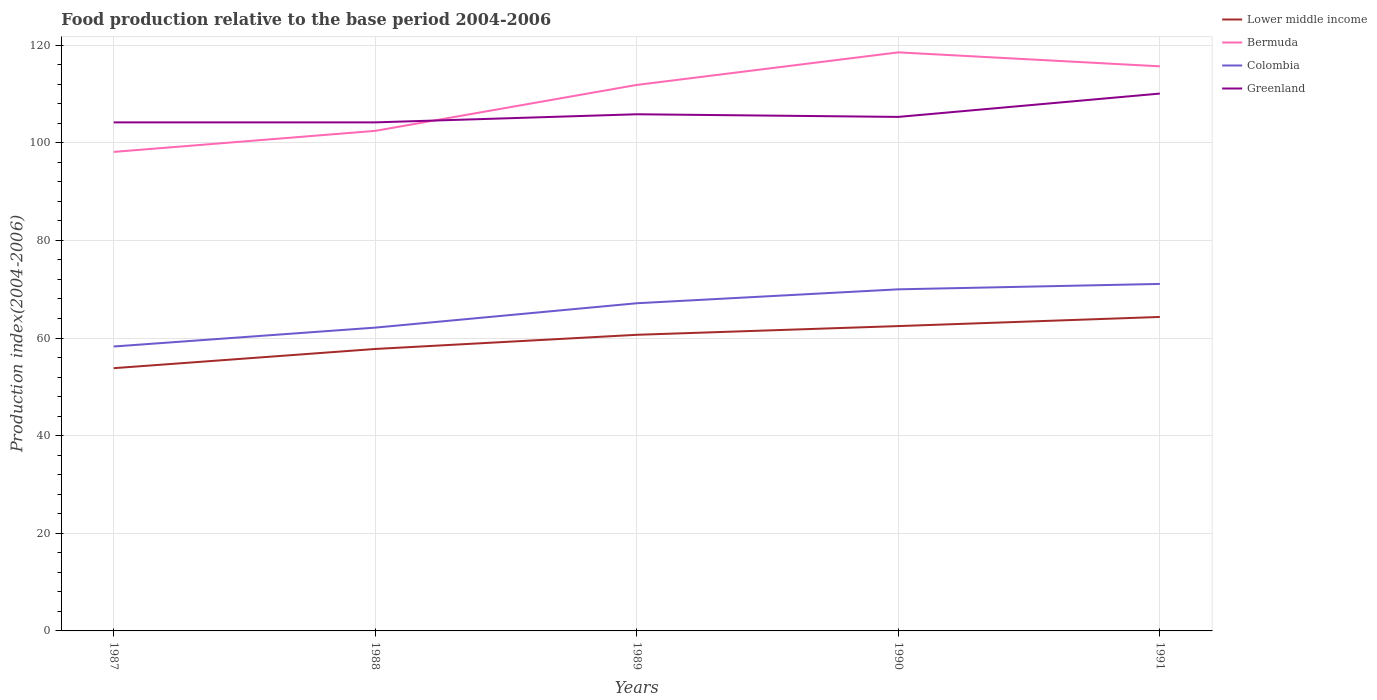Is the number of lines equal to the number of legend labels?
Offer a terse response. Yes. Across all years, what is the maximum food production index in Colombia?
Provide a short and direct response. 58.26. What is the total food production index in Greenland in the graph?
Your answer should be compact. -1.12. What is the difference between the highest and the second highest food production index in Colombia?
Make the answer very short. 12.82. What is the difference between the highest and the lowest food production index in Bermuda?
Offer a very short reply. 3. How many lines are there?
Ensure brevity in your answer.  4. How many years are there in the graph?
Offer a terse response. 5. Does the graph contain grids?
Provide a succinct answer. Yes. Where does the legend appear in the graph?
Provide a succinct answer. Top right. How many legend labels are there?
Your answer should be compact. 4. How are the legend labels stacked?
Your answer should be very brief. Vertical. What is the title of the graph?
Your response must be concise. Food production relative to the base period 2004-2006. Does "Middle income" appear as one of the legend labels in the graph?
Offer a terse response. No. What is the label or title of the Y-axis?
Give a very brief answer. Production index(2004-2006). What is the Production index(2004-2006) in Lower middle income in 1987?
Give a very brief answer. 53.82. What is the Production index(2004-2006) in Bermuda in 1987?
Give a very brief answer. 98.12. What is the Production index(2004-2006) in Colombia in 1987?
Your answer should be compact. 58.26. What is the Production index(2004-2006) in Greenland in 1987?
Offer a terse response. 104.17. What is the Production index(2004-2006) in Lower middle income in 1988?
Offer a very short reply. 57.75. What is the Production index(2004-2006) in Bermuda in 1988?
Ensure brevity in your answer.  102.43. What is the Production index(2004-2006) of Colombia in 1988?
Offer a terse response. 62.13. What is the Production index(2004-2006) of Greenland in 1988?
Make the answer very short. 104.17. What is the Production index(2004-2006) of Lower middle income in 1989?
Your answer should be compact. 60.66. What is the Production index(2004-2006) in Bermuda in 1989?
Offer a terse response. 111.84. What is the Production index(2004-2006) in Colombia in 1989?
Ensure brevity in your answer.  67.12. What is the Production index(2004-2006) in Greenland in 1989?
Your answer should be very brief. 105.83. What is the Production index(2004-2006) in Lower middle income in 1990?
Your answer should be very brief. 62.44. What is the Production index(2004-2006) in Bermuda in 1990?
Provide a succinct answer. 118.51. What is the Production index(2004-2006) of Colombia in 1990?
Keep it short and to the point. 69.97. What is the Production index(2004-2006) of Greenland in 1990?
Keep it short and to the point. 105.29. What is the Production index(2004-2006) in Lower middle income in 1991?
Offer a terse response. 64.31. What is the Production index(2004-2006) in Bermuda in 1991?
Provide a succinct answer. 115.65. What is the Production index(2004-2006) in Colombia in 1991?
Offer a terse response. 71.08. What is the Production index(2004-2006) in Greenland in 1991?
Keep it short and to the point. 110.07. Across all years, what is the maximum Production index(2004-2006) in Lower middle income?
Ensure brevity in your answer.  64.31. Across all years, what is the maximum Production index(2004-2006) of Bermuda?
Ensure brevity in your answer.  118.51. Across all years, what is the maximum Production index(2004-2006) in Colombia?
Ensure brevity in your answer.  71.08. Across all years, what is the maximum Production index(2004-2006) in Greenland?
Make the answer very short. 110.07. Across all years, what is the minimum Production index(2004-2006) of Lower middle income?
Ensure brevity in your answer.  53.82. Across all years, what is the minimum Production index(2004-2006) in Bermuda?
Your answer should be compact. 98.12. Across all years, what is the minimum Production index(2004-2006) in Colombia?
Your response must be concise. 58.26. Across all years, what is the minimum Production index(2004-2006) of Greenland?
Provide a succinct answer. 104.17. What is the total Production index(2004-2006) in Lower middle income in the graph?
Ensure brevity in your answer.  298.99. What is the total Production index(2004-2006) of Bermuda in the graph?
Ensure brevity in your answer.  546.55. What is the total Production index(2004-2006) in Colombia in the graph?
Provide a succinct answer. 328.56. What is the total Production index(2004-2006) in Greenland in the graph?
Offer a very short reply. 529.53. What is the difference between the Production index(2004-2006) of Lower middle income in 1987 and that in 1988?
Provide a succinct answer. -3.93. What is the difference between the Production index(2004-2006) of Bermuda in 1987 and that in 1988?
Give a very brief answer. -4.31. What is the difference between the Production index(2004-2006) of Colombia in 1987 and that in 1988?
Offer a terse response. -3.87. What is the difference between the Production index(2004-2006) in Lower middle income in 1987 and that in 1989?
Your answer should be very brief. -6.84. What is the difference between the Production index(2004-2006) in Bermuda in 1987 and that in 1989?
Your answer should be very brief. -13.72. What is the difference between the Production index(2004-2006) of Colombia in 1987 and that in 1989?
Provide a succinct answer. -8.86. What is the difference between the Production index(2004-2006) of Greenland in 1987 and that in 1989?
Make the answer very short. -1.66. What is the difference between the Production index(2004-2006) of Lower middle income in 1987 and that in 1990?
Make the answer very short. -8.63. What is the difference between the Production index(2004-2006) of Bermuda in 1987 and that in 1990?
Offer a very short reply. -20.39. What is the difference between the Production index(2004-2006) in Colombia in 1987 and that in 1990?
Offer a very short reply. -11.71. What is the difference between the Production index(2004-2006) in Greenland in 1987 and that in 1990?
Offer a terse response. -1.12. What is the difference between the Production index(2004-2006) in Lower middle income in 1987 and that in 1991?
Give a very brief answer. -10.49. What is the difference between the Production index(2004-2006) of Bermuda in 1987 and that in 1991?
Ensure brevity in your answer.  -17.53. What is the difference between the Production index(2004-2006) of Colombia in 1987 and that in 1991?
Your answer should be compact. -12.82. What is the difference between the Production index(2004-2006) in Greenland in 1987 and that in 1991?
Ensure brevity in your answer.  -5.9. What is the difference between the Production index(2004-2006) in Lower middle income in 1988 and that in 1989?
Ensure brevity in your answer.  -2.9. What is the difference between the Production index(2004-2006) in Bermuda in 1988 and that in 1989?
Provide a short and direct response. -9.41. What is the difference between the Production index(2004-2006) in Colombia in 1988 and that in 1989?
Provide a short and direct response. -4.99. What is the difference between the Production index(2004-2006) in Greenland in 1988 and that in 1989?
Provide a succinct answer. -1.66. What is the difference between the Production index(2004-2006) of Lower middle income in 1988 and that in 1990?
Offer a terse response. -4.69. What is the difference between the Production index(2004-2006) of Bermuda in 1988 and that in 1990?
Provide a short and direct response. -16.08. What is the difference between the Production index(2004-2006) of Colombia in 1988 and that in 1990?
Offer a terse response. -7.84. What is the difference between the Production index(2004-2006) in Greenland in 1988 and that in 1990?
Your answer should be very brief. -1.12. What is the difference between the Production index(2004-2006) in Lower middle income in 1988 and that in 1991?
Your answer should be compact. -6.56. What is the difference between the Production index(2004-2006) in Bermuda in 1988 and that in 1991?
Make the answer very short. -13.22. What is the difference between the Production index(2004-2006) of Colombia in 1988 and that in 1991?
Make the answer very short. -8.95. What is the difference between the Production index(2004-2006) in Greenland in 1988 and that in 1991?
Make the answer very short. -5.9. What is the difference between the Production index(2004-2006) of Lower middle income in 1989 and that in 1990?
Your response must be concise. -1.79. What is the difference between the Production index(2004-2006) of Bermuda in 1989 and that in 1990?
Your response must be concise. -6.67. What is the difference between the Production index(2004-2006) of Colombia in 1989 and that in 1990?
Provide a succinct answer. -2.85. What is the difference between the Production index(2004-2006) of Greenland in 1989 and that in 1990?
Ensure brevity in your answer.  0.54. What is the difference between the Production index(2004-2006) of Lower middle income in 1989 and that in 1991?
Ensure brevity in your answer.  -3.66. What is the difference between the Production index(2004-2006) of Bermuda in 1989 and that in 1991?
Keep it short and to the point. -3.81. What is the difference between the Production index(2004-2006) of Colombia in 1989 and that in 1991?
Provide a succinct answer. -3.96. What is the difference between the Production index(2004-2006) in Greenland in 1989 and that in 1991?
Offer a terse response. -4.24. What is the difference between the Production index(2004-2006) of Lower middle income in 1990 and that in 1991?
Offer a terse response. -1.87. What is the difference between the Production index(2004-2006) of Bermuda in 1990 and that in 1991?
Give a very brief answer. 2.86. What is the difference between the Production index(2004-2006) of Colombia in 1990 and that in 1991?
Your answer should be compact. -1.11. What is the difference between the Production index(2004-2006) in Greenland in 1990 and that in 1991?
Offer a very short reply. -4.78. What is the difference between the Production index(2004-2006) in Lower middle income in 1987 and the Production index(2004-2006) in Bermuda in 1988?
Your response must be concise. -48.61. What is the difference between the Production index(2004-2006) of Lower middle income in 1987 and the Production index(2004-2006) of Colombia in 1988?
Give a very brief answer. -8.31. What is the difference between the Production index(2004-2006) of Lower middle income in 1987 and the Production index(2004-2006) of Greenland in 1988?
Offer a terse response. -50.35. What is the difference between the Production index(2004-2006) in Bermuda in 1987 and the Production index(2004-2006) in Colombia in 1988?
Your answer should be compact. 35.99. What is the difference between the Production index(2004-2006) in Bermuda in 1987 and the Production index(2004-2006) in Greenland in 1988?
Offer a very short reply. -6.05. What is the difference between the Production index(2004-2006) of Colombia in 1987 and the Production index(2004-2006) of Greenland in 1988?
Provide a short and direct response. -45.91. What is the difference between the Production index(2004-2006) of Lower middle income in 1987 and the Production index(2004-2006) of Bermuda in 1989?
Give a very brief answer. -58.02. What is the difference between the Production index(2004-2006) in Lower middle income in 1987 and the Production index(2004-2006) in Colombia in 1989?
Provide a short and direct response. -13.3. What is the difference between the Production index(2004-2006) in Lower middle income in 1987 and the Production index(2004-2006) in Greenland in 1989?
Ensure brevity in your answer.  -52.01. What is the difference between the Production index(2004-2006) in Bermuda in 1987 and the Production index(2004-2006) in Colombia in 1989?
Your answer should be compact. 31. What is the difference between the Production index(2004-2006) in Bermuda in 1987 and the Production index(2004-2006) in Greenland in 1989?
Offer a terse response. -7.71. What is the difference between the Production index(2004-2006) of Colombia in 1987 and the Production index(2004-2006) of Greenland in 1989?
Keep it short and to the point. -47.57. What is the difference between the Production index(2004-2006) in Lower middle income in 1987 and the Production index(2004-2006) in Bermuda in 1990?
Provide a succinct answer. -64.69. What is the difference between the Production index(2004-2006) in Lower middle income in 1987 and the Production index(2004-2006) in Colombia in 1990?
Offer a very short reply. -16.15. What is the difference between the Production index(2004-2006) of Lower middle income in 1987 and the Production index(2004-2006) of Greenland in 1990?
Ensure brevity in your answer.  -51.47. What is the difference between the Production index(2004-2006) of Bermuda in 1987 and the Production index(2004-2006) of Colombia in 1990?
Give a very brief answer. 28.15. What is the difference between the Production index(2004-2006) of Bermuda in 1987 and the Production index(2004-2006) of Greenland in 1990?
Your response must be concise. -7.17. What is the difference between the Production index(2004-2006) in Colombia in 1987 and the Production index(2004-2006) in Greenland in 1990?
Offer a terse response. -47.03. What is the difference between the Production index(2004-2006) of Lower middle income in 1987 and the Production index(2004-2006) of Bermuda in 1991?
Keep it short and to the point. -61.83. What is the difference between the Production index(2004-2006) of Lower middle income in 1987 and the Production index(2004-2006) of Colombia in 1991?
Ensure brevity in your answer.  -17.26. What is the difference between the Production index(2004-2006) in Lower middle income in 1987 and the Production index(2004-2006) in Greenland in 1991?
Provide a short and direct response. -56.25. What is the difference between the Production index(2004-2006) in Bermuda in 1987 and the Production index(2004-2006) in Colombia in 1991?
Provide a short and direct response. 27.04. What is the difference between the Production index(2004-2006) of Bermuda in 1987 and the Production index(2004-2006) of Greenland in 1991?
Offer a terse response. -11.95. What is the difference between the Production index(2004-2006) of Colombia in 1987 and the Production index(2004-2006) of Greenland in 1991?
Your response must be concise. -51.81. What is the difference between the Production index(2004-2006) of Lower middle income in 1988 and the Production index(2004-2006) of Bermuda in 1989?
Offer a terse response. -54.09. What is the difference between the Production index(2004-2006) in Lower middle income in 1988 and the Production index(2004-2006) in Colombia in 1989?
Provide a succinct answer. -9.37. What is the difference between the Production index(2004-2006) in Lower middle income in 1988 and the Production index(2004-2006) in Greenland in 1989?
Your response must be concise. -48.08. What is the difference between the Production index(2004-2006) of Bermuda in 1988 and the Production index(2004-2006) of Colombia in 1989?
Your answer should be very brief. 35.31. What is the difference between the Production index(2004-2006) of Colombia in 1988 and the Production index(2004-2006) of Greenland in 1989?
Make the answer very short. -43.7. What is the difference between the Production index(2004-2006) in Lower middle income in 1988 and the Production index(2004-2006) in Bermuda in 1990?
Offer a terse response. -60.76. What is the difference between the Production index(2004-2006) in Lower middle income in 1988 and the Production index(2004-2006) in Colombia in 1990?
Your answer should be very brief. -12.22. What is the difference between the Production index(2004-2006) of Lower middle income in 1988 and the Production index(2004-2006) of Greenland in 1990?
Provide a short and direct response. -47.54. What is the difference between the Production index(2004-2006) in Bermuda in 1988 and the Production index(2004-2006) in Colombia in 1990?
Your response must be concise. 32.46. What is the difference between the Production index(2004-2006) of Bermuda in 1988 and the Production index(2004-2006) of Greenland in 1990?
Offer a very short reply. -2.86. What is the difference between the Production index(2004-2006) of Colombia in 1988 and the Production index(2004-2006) of Greenland in 1990?
Provide a succinct answer. -43.16. What is the difference between the Production index(2004-2006) in Lower middle income in 1988 and the Production index(2004-2006) in Bermuda in 1991?
Provide a succinct answer. -57.9. What is the difference between the Production index(2004-2006) in Lower middle income in 1988 and the Production index(2004-2006) in Colombia in 1991?
Make the answer very short. -13.33. What is the difference between the Production index(2004-2006) of Lower middle income in 1988 and the Production index(2004-2006) of Greenland in 1991?
Keep it short and to the point. -52.32. What is the difference between the Production index(2004-2006) in Bermuda in 1988 and the Production index(2004-2006) in Colombia in 1991?
Your answer should be very brief. 31.35. What is the difference between the Production index(2004-2006) of Bermuda in 1988 and the Production index(2004-2006) of Greenland in 1991?
Give a very brief answer. -7.64. What is the difference between the Production index(2004-2006) of Colombia in 1988 and the Production index(2004-2006) of Greenland in 1991?
Your response must be concise. -47.94. What is the difference between the Production index(2004-2006) in Lower middle income in 1989 and the Production index(2004-2006) in Bermuda in 1990?
Your answer should be very brief. -57.85. What is the difference between the Production index(2004-2006) of Lower middle income in 1989 and the Production index(2004-2006) of Colombia in 1990?
Keep it short and to the point. -9.31. What is the difference between the Production index(2004-2006) of Lower middle income in 1989 and the Production index(2004-2006) of Greenland in 1990?
Offer a very short reply. -44.63. What is the difference between the Production index(2004-2006) of Bermuda in 1989 and the Production index(2004-2006) of Colombia in 1990?
Your response must be concise. 41.87. What is the difference between the Production index(2004-2006) in Bermuda in 1989 and the Production index(2004-2006) in Greenland in 1990?
Ensure brevity in your answer.  6.55. What is the difference between the Production index(2004-2006) in Colombia in 1989 and the Production index(2004-2006) in Greenland in 1990?
Provide a short and direct response. -38.17. What is the difference between the Production index(2004-2006) in Lower middle income in 1989 and the Production index(2004-2006) in Bermuda in 1991?
Your answer should be very brief. -54.99. What is the difference between the Production index(2004-2006) of Lower middle income in 1989 and the Production index(2004-2006) of Colombia in 1991?
Ensure brevity in your answer.  -10.42. What is the difference between the Production index(2004-2006) of Lower middle income in 1989 and the Production index(2004-2006) of Greenland in 1991?
Your answer should be very brief. -49.41. What is the difference between the Production index(2004-2006) in Bermuda in 1989 and the Production index(2004-2006) in Colombia in 1991?
Ensure brevity in your answer.  40.76. What is the difference between the Production index(2004-2006) in Bermuda in 1989 and the Production index(2004-2006) in Greenland in 1991?
Provide a short and direct response. 1.77. What is the difference between the Production index(2004-2006) in Colombia in 1989 and the Production index(2004-2006) in Greenland in 1991?
Your response must be concise. -42.95. What is the difference between the Production index(2004-2006) in Lower middle income in 1990 and the Production index(2004-2006) in Bermuda in 1991?
Keep it short and to the point. -53.21. What is the difference between the Production index(2004-2006) of Lower middle income in 1990 and the Production index(2004-2006) of Colombia in 1991?
Provide a short and direct response. -8.64. What is the difference between the Production index(2004-2006) in Lower middle income in 1990 and the Production index(2004-2006) in Greenland in 1991?
Ensure brevity in your answer.  -47.63. What is the difference between the Production index(2004-2006) of Bermuda in 1990 and the Production index(2004-2006) of Colombia in 1991?
Give a very brief answer. 47.43. What is the difference between the Production index(2004-2006) in Bermuda in 1990 and the Production index(2004-2006) in Greenland in 1991?
Your response must be concise. 8.44. What is the difference between the Production index(2004-2006) in Colombia in 1990 and the Production index(2004-2006) in Greenland in 1991?
Provide a succinct answer. -40.1. What is the average Production index(2004-2006) in Lower middle income per year?
Your answer should be very brief. 59.8. What is the average Production index(2004-2006) in Bermuda per year?
Ensure brevity in your answer.  109.31. What is the average Production index(2004-2006) of Colombia per year?
Give a very brief answer. 65.71. What is the average Production index(2004-2006) of Greenland per year?
Ensure brevity in your answer.  105.91. In the year 1987, what is the difference between the Production index(2004-2006) in Lower middle income and Production index(2004-2006) in Bermuda?
Keep it short and to the point. -44.3. In the year 1987, what is the difference between the Production index(2004-2006) in Lower middle income and Production index(2004-2006) in Colombia?
Give a very brief answer. -4.44. In the year 1987, what is the difference between the Production index(2004-2006) in Lower middle income and Production index(2004-2006) in Greenland?
Your answer should be very brief. -50.35. In the year 1987, what is the difference between the Production index(2004-2006) in Bermuda and Production index(2004-2006) in Colombia?
Provide a short and direct response. 39.86. In the year 1987, what is the difference between the Production index(2004-2006) in Bermuda and Production index(2004-2006) in Greenland?
Provide a short and direct response. -6.05. In the year 1987, what is the difference between the Production index(2004-2006) of Colombia and Production index(2004-2006) of Greenland?
Offer a terse response. -45.91. In the year 1988, what is the difference between the Production index(2004-2006) in Lower middle income and Production index(2004-2006) in Bermuda?
Your response must be concise. -44.68. In the year 1988, what is the difference between the Production index(2004-2006) of Lower middle income and Production index(2004-2006) of Colombia?
Offer a very short reply. -4.38. In the year 1988, what is the difference between the Production index(2004-2006) of Lower middle income and Production index(2004-2006) of Greenland?
Provide a succinct answer. -46.42. In the year 1988, what is the difference between the Production index(2004-2006) in Bermuda and Production index(2004-2006) in Colombia?
Provide a succinct answer. 40.3. In the year 1988, what is the difference between the Production index(2004-2006) of Bermuda and Production index(2004-2006) of Greenland?
Your answer should be very brief. -1.74. In the year 1988, what is the difference between the Production index(2004-2006) in Colombia and Production index(2004-2006) in Greenland?
Your answer should be very brief. -42.04. In the year 1989, what is the difference between the Production index(2004-2006) in Lower middle income and Production index(2004-2006) in Bermuda?
Keep it short and to the point. -51.18. In the year 1989, what is the difference between the Production index(2004-2006) in Lower middle income and Production index(2004-2006) in Colombia?
Your answer should be very brief. -6.46. In the year 1989, what is the difference between the Production index(2004-2006) of Lower middle income and Production index(2004-2006) of Greenland?
Your response must be concise. -45.17. In the year 1989, what is the difference between the Production index(2004-2006) of Bermuda and Production index(2004-2006) of Colombia?
Offer a very short reply. 44.72. In the year 1989, what is the difference between the Production index(2004-2006) in Bermuda and Production index(2004-2006) in Greenland?
Make the answer very short. 6.01. In the year 1989, what is the difference between the Production index(2004-2006) of Colombia and Production index(2004-2006) of Greenland?
Ensure brevity in your answer.  -38.71. In the year 1990, what is the difference between the Production index(2004-2006) in Lower middle income and Production index(2004-2006) in Bermuda?
Your answer should be very brief. -56.07. In the year 1990, what is the difference between the Production index(2004-2006) of Lower middle income and Production index(2004-2006) of Colombia?
Make the answer very short. -7.53. In the year 1990, what is the difference between the Production index(2004-2006) in Lower middle income and Production index(2004-2006) in Greenland?
Keep it short and to the point. -42.85. In the year 1990, what is the difference between the Production index(2004-2006) in Bermuda and Production index(2004-2006) in Colombia?
Your response must be concise. 48.54. In the year 1990, what is the difference between the Production index(2004-2006) of Bermuda and Production index(2004-2006) of Greenland?
Offer a very short reply. 13.22. In the year 1990, what is the difference between the Production index(2004-2006) in Colombia and Production index(2004-2006) in Greenland?
Make the answer very short. -35.32. In the year 1991, what is the difference between the Production index(2004-2006) of Lower middle income and Production index(2004-2006) of Bermuda?
Your answer should be compact. -51.34. In the year 1991, what is the difference between the Production index(2004-2006) in Lower middle income and Production index(2004-2006) in Colombia?
Your answer should be compact. -6.77. In the year 1991, what is the difference between the Production index(2004-2006) in Lower middle income and Production index(2004-2006) in Greenland?
Ensure brevity in your answer.  -45.76. In the year 1991, what is the difference between the Production index(2004-2006) in Bermuda and Production index(2004-2006) in Colombia?
Provide a succinct answer. 44.57. In the year 1991, what is the difference between the Production index(2004-2006) of Bermuda and Production index(2004-2006) of Greenland?
Keep it short and to the point. 5.58. In the year 1991, what is the difference between the Production index(2004-2006) of Colombia and Production index(2004-2006) of Greenland?
Offer a very short reply. -38.99. What is the ratio of the Production index(2004-2006) of Lower middle income in 1987 to that in 1988?
Offer a very short reply. 0.93. What is the ratio of the Production index(2004-2006) of Bermuda in 1987 to that in 1988?
Keep it short and to the point. 0.96. What is the ratio of the Production index(2004-2006) in Colombia in 1987 to that in 1988?
Provide a short and direct response. 0.94. What is the ratio of the Production index(2004-2006) of Lower middle income in 1987 to that in 1989?
Your answer should be compact. 0.89. What is the ratio of the Production index(2004-2006) in Bermuda in 1987 to that in 1989?
Offer a terse response. 0.88. What is the ratio of the Production index(2004-2006) in Colombia in 1987 to that in 1989?
Your answer should be very brief. 0.87. What is the ratio of the Production index(2004-2006) in Greenland in 1987 to that in 1989?
Your answer should be compact. 0.98. What is the ratio of the Production index(2004-2006) in Lower middle income in 1987 to that in 1990?
Provide a short and direct response. 0.86. What is the ratio of the Production index(2004-2006) in Bermuda in 1987 to that in 1990?
Ensure brevity in your answer.  0.83. What is the ratio of the Production index(2004-2006) in Colombia in 1987 to that in 1990?
Provide a succinct answer. 0.83. What is the ratio of the Production index(2004-2006) in Greenland in 1987 to that in 1990?
Your response must be concise. 0.99. What is the ratio of the Production index(2004-2006) in Lower middle income in 1987 to that in 1991?
Ensure brevity in your answer.  0.84. What is the ratio of the Production index(2004-2006) of Bermuda in 1987 to that in 1991?
Provide a succinct answer. 0.85. What is the ratio of the Production index(2004-2006) in Colombia in 1987 to that in 1991?
Ensure brevity in your answer.  0.82. What is the ratio of the Production index(2004-2006) in Greenland in 1987 to that in 1991?
Give a very brief answer. 0.95. What is the ratio of the Production index(2004-2006) of Lower middle income in 1988 to that in 1989?
Ensure brevity in your answer.  0.95. What is the ratio of the Production index(2004-2006) in Bermuda in 1988 to that in 1989?
Provide a succinct answer. 0.92. What is the ratio of the Production index(2004-2006) of Colombia in 1988 to that in 1989?
Ensure brevity in your answer.  0.93. What is the ratio of the Production index(2004-2006) in Greenland in 1988 to that in 1989?
Keep it short and to the point. 0.98. What is the ratio of the Production index(2004-2006) in Lower middle income in 1988 to that in 1990?
Ensure brevity in your answer.  0.92. What is the ratio of the Production index(2004-2006) in Bermuda in 1988 to that in 1990?
Make the answer very short. 0.86. What is the ratio of the Production index(2004-2006) of Colombia in 1988 to that in 1990?
Ensure brevity in your answer.  0.89. What is the ratio of the Production index(2004-2006) in Lower middle income in 1988 to that in 1991?
Keep it short and to the point. 0.9. What is the ratio of the Production index(2004-2006) of Bermuda in 1988 to that in 1991?
Provide a succinct answer. 0.89. What is the ratio of the Production index(2004-2006) in Colombia in 1988 to that in 1991?
Give a very brief answer. 0.87. What is the ratio of the Production index(2004-2006) in Greenland in 1988 to that in 1991?
Offer a very short reply. 0.95. What is the ratio of the Production index(2004-2006) of Lower middle income in 1989 to that in 1990?
Provide a short and direct response. 0.97. What is the ratio of the Production index(2004-2006) of Bermuda in 1989 to that in 1990?
Offer a very short reply. 0.94. What is the ratio of the Production index(2004-2006) in Colombia in 1989 to that in 1990?
Your answer should be compact. 0.96. What is the ratio of the Production index(2004-2006) of Lower middle income in 1989 to that in 1991?
Provide a succinct answer. 0.94. What is the ratio of the Production index(2004-2006) in Bermuda in 1989 to that in 1991?
Ensure brevity in your answer.  0.97. What is the ratio of the Production index(2004-2006) in Colombia in 1989 to that in 1991?
Offer a very short reply. 0.94. What is the ratio of the Production index(2004-2006) in Greenland in 1989 to that in 1991?
Make the answer very short. 0.96. What is the ratio of the Production index(2004-2006) of Lower middle income in 1990 to that in 1991?
Your answer should be very brief. 0.97. What is the ratio of the Production index(2004-2006) in Bermuda in 1990 to that in 1991?
Give a very brief answer. 1.02. What is the ratio of the Production index(2004-2006) in Colombia in 1990 to that in 1991?
Your answer should be very brief. 0.98. What is the ratio of the Production index(2004-2006) of Greenland in 1990 to that in 1991?
Offer a very short reply. 0.96. What is the difference between the highest and the second highest Production index(2004-2006) of Lower middle income?
Your response must be concise. 1.87. What is the difference between the highest and the second highest Production index(2004-2006) in Bermuda?
Offer a terse response. 2.86. What is the difference between the highest and the second highest Production index(2004-2006) of Colombia?
Offer a terse response. 1.11. What is the difference between the highest and the second highest Production index(2004-2006) in Greenland?
Provide a short and direct response. 4.24. What is the difference between the highest and the lowest Production index(2004-2006) in Lower middle income?
Your answer should be very brief. 10.49. What is the difference between the highest and the lowest Production index(2004-2006) of Bermuda?
Provide a short and direct response. 20.39. What is the difference between the highest and the lowest Production index(2004-2006) in Colombia?
Your answer should be very brief. 12.82. What is the difference between the highest and the lowest Production index(2004-2006) of Greenland?
Offer a very short reply. 5.9. 